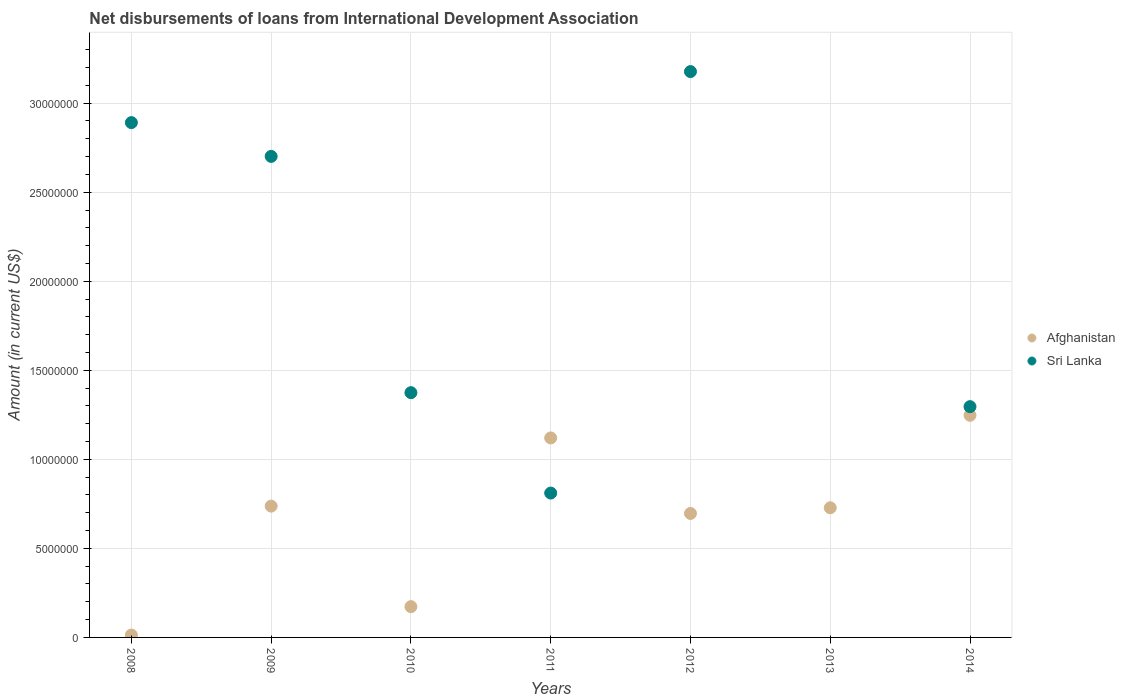How many different coloured dotlines are there?
Keep it short and to the point. 2. Is the number of dotlines equal to the number of legend labels?
Make the answer very short. No. What is the amount of loans disbursed in Afghanistan in 2012?
Offer a terse response. 6.96e+06. Across all years, what is the maximum amount of loans disbursed in Afghanistan?
Offer a very short reply. 1.25e+07. Across all years, what is the minimum amount of loans disbursed in Sri Lanka?
Give a very brief answer. 0. What is the total amount of loans disbursed in Afghanistan in the graph?
Give a very brief answer. 4.72e+07. What is the difference between the amount of loans disbursed in Sri Lanka in 2008 and that in 2014?
Provide a succinct answer. 1.59e+07. What is the difference between the amount of loans disbursed in Afghanistan in 2008 and the amount of loans disbursed in Sri Lanka in 2010?
Give a very brief answer. -1.36e+07. What is the average amount of loans disbursed in Afghanistan per year?
Ensure brevity in your answer.  6.74e+06. In the year 2009, what is the difference between the amount of loans disbursed in Afghanistan and amount of loans disbursed in Sri Lanka?
Keep it short and to the point. -1.96e+07. What is the ratio of the amount of loans disbursed in Afghanistan in 2009 to that in 2013?
Make the answer very short. 1.01. What is the difference between the highest and the second highest amount of loans disbursed in Afghanistan?
Your answer should be compact. 1.27e+06. What is the difference between the highest and the lowest amount of loans disbursed in Sri Lanka?
Your answer should be very brief. 3.18e+07. In how many years, is the amount of loans disbursed in Sri Lanka greater than the average amount of loans disbursed in Sri Lanka taken over all years?
Offer a terse response. 3. Does the amount of loans disbursed in Afghanistan monotonically increase over the years?
Your answer should be very brief. No. How many dotlines are there?
Your response must be concise. 2. What is the difference between two consecutive major ticks on the Y-axis?
Give a very brief answer. 5.00e+06. Does the graph contain grids?
Provide a succinct answer. Yes. How many legend labels are there?
Give a very brief answer. 2. How are the legend labels stacked?
Ensure brevity in your answer.  Vertical. What is the title of the graph?
Your answer should be very brief. Net disbursements of loans from International Development Association. What is the Amount (in current US$) in Afghanistan in 2008?
Provide a succinct answer. 1.33e+05. What is the Amount (in current US$) of Sri Lanka in 2008?
Ensure brevity in your answer.  2.89e+07. What is the Amount (in current US$) of Afghanistan in 2009?
Give a very brief answer. 7.37e+06. What is the Amount (in current US$) of Sri Lanka in 2009?
Your answer should be compact. 2.70e+07. What is the Amount (in current US$) in Afghanistan in 2010?
Offer a very short reply. 1.73e+06. What is the Amount (in current US$) of Sri Lanka in 2010?
Ensure brevity in your answer.  1.37e+07. What is the Amount (in current US$) of Afghanistan in 2011?
Keep it short and to the point. 1.12e+07. What is the Amount (in current US$) in Sri Lanka in 2011?
Your answer should be compact. 8.11e+06. What is the Amount (in current US$) of Afghanistan in 2012?
Give a very brief answer. 6.96e+06. What is the Amount (in current US$) of Sri Lanka in 2012?
Offer a terse response. 3.18e+07. What is the Amount (in current US$) in Afghanistan in 2013?
Offer a terse response. 7.28e+06. What is the Amount (in current US$) of Sri Lanka in 2013?
Keep it short and to the point. 0. What is the Amount (in current US$) in Afghanistan in 2014?
Your response must be concise. 1.25e+07. What is the Amount (in current US$) of Sri Lanka in 2014?
Your answer should be compact. 1.30e+07. Across all years, what is the maximum Amount (in current US$) in Afghanistan?
Your answer should be compact. 1.25e+07. Across all years, what is the maximum Amount (in current US$) in Sri Lanka?
Ensure brevity in your answer.  3.18e+07. Across all years, what is the minimum Amount (in current US$) in Afghanistan?
Provide a short and direct response. 1.33e+05. Across all years, what is the minimum Amount (in current US$) of Sri Lanka?
Ensure brevity in your answer.  0. What is the total Amount (in current US$) in Afghanistan in the graph?
Provide a short and direct response. 4.72e+07. What is the total Amount (in current US$) in Sri Lanka in the graph?
Give a very brief answer. 1.22e+08. What is the difference between the Amount (in current US$) in Afghanistan in 2008 and that in 2009?
Your response must be concise. -7.24e+06. What is the difference between the Amount (in current US$) of Sri Lanka in 2008 and that in 2009?
Give a very brief answer. 1.90e+06. What is the difference between the Amount (in current US$) in Afghanistan in 2008 and that in 2010?
Offer a very short reply. -1.60e+06. What is the difference between the Amount (in current US$) in Sri Lanka in 2008 and that in 2010?
Offer a very short reply. 1.52e+07. What is the difference between the Amount (in current US$) of Afghanistan in 2008 and that in 2011?
Offer a very short reply. -1.11e+07. What is the difference between the Amount (in current US$) of Sri Lanka in 2008 and that in 2011?
Your answer should be compact. 2.08e+07. What is the difference between the Amount (in current US$) in Afghanistan in 2008 and that in 2012?
Keep it short and to the point. -6.83e+06. What is the difference between the Amount (in current US$) in Sri Lanka in 2008 and that in 2012?
Provide a succinct answer. -2.86e+06. What is the difference between the Amount (in current US$) of Afghanistan in 2008 and that in 2013?
Your answer should be very brief. -7.15e+06. What is the difference between the Amount (in current US$) in Afghanistan in 2008 and that in 2014?
Make the answer very short. -1.23e+07. What is the difference between the Amount (in current US$) of Sri Lanka in 2008 and that in 2014?
Make the answer very short. 1.59e+07. What is the difference between the Amount (in current US$) of Afghanistan in 2009 and that in 2010?
Give a very brief answer. 5.64e+06. What is the difference between the Amount (in current US$) of Sri Lanka in 2009 and that in 2010?
Provide a succinct answer. 1.33e+07. What is the difference between the Amount (in current US$) of Afghanistan in 2009 and that in 2011?
Provide a short and direct response. -3.83e+06. What is the difference between the Amount (in current US$) of Sri Lanka in 2009 and that in 2011?
Your answer should be compact. 1.89e+07. What is the difference between the Amount (in current US$) of Afghanistan in 2009 and that in 2012?
Keep it short and to the point. 4.12e+05. What is the difference between the Amount (in current US$) in Sri Lanka in 2009 and that in 2012?
Your answer should be compact. -4.76e+06. What is the difference between the Amount (in current US$) in Afghanistan in 2009 and that in 2013?
Give a very brief answer. 9.30e+04. What is the difference between the Amount (in current US$) in Afghanistan in 2009 and that in 2014?
Your answer should be compact. -5.10e+06. What is the difference between the Amount (in current US$) of Sri Lanka in 2009 and that in 2014?
Your answer should be very brief. 1.41e+07. What is the difference between the Amount (in current US$) in Afghanistan in 2010 and that in 2011?
Your answer should be very brief. -9.47e+06. What is the difference between the Amount (in current US$) of Sri Lanka in 2010 and that in 2011?
Provide a succinct answer. 5.64e+06. What is the difference between the Amount (in current US$) in Afghanistan in 2010 and that in 2012?
Give a very brief answer. -5.23e+06. What is the difference between the Amount (in current US$) in Sri Lanka in 2010 and that in 2012?
Offer a terse response. -1.80e+07. What is the difference between the Amount (in current US$) in Afghanistan in 2010 and that in 2013?
Keep it short and to the point. -5.55e+06. What is the difference between the Amount (in current US$) of Afghanistan in 2010 and that in 2014?
Ensure brevity in your answer.  -1.07e+07. What is the difference between the Amount (in current US$) of Sri Lanka in 2010 and that in 2014?
Provide a succinct answer. 7.85e+05. What is the difference between the Amount (in current US$) of Afghanistan in 2011 and that in 2012?
Ensure brevity in your answer.  4.24e+06. What is the difference between the Amount (in current US$) of Sri Lanka in 2011 and that in 2012?
Your answer should be compact. -2.37e+07. What is the difference between the Amount (in current US$) of Afghanistan in 2011 and that in 2013?
Your response must be concise. 3.92e+06. What is the difference between the Amount (in current US$) in Afghanistan in 2011 and that in 2014?
Offer a very short reply. -1.27e+06. What is the difference between the Amount (in current US$) in Sri Lanka in 2011 and that in 2014?
Make the answer very short. -4.85e+06. What is the difference between the Amount (in current US$) in Afghanistan in 2012 and that in 2013?
Your response must be concise. -3.19e+05. What is the difference between the Amount (in current US$) of Afghanistan in 2012 and that in 2014?
Make the answer very short. -5.51e+06. What is the difference between the Amount (in current US$) in Sri Lanka in 2012 and that in 2014?
Offer a terse response. 1.88e+07. What is the difference between the Amount (in current US$) of Afghanistan in 2013 and that in 2014?
Your answer should be very brief. -5.19e+06. What is the difference between the Amount (in current US$) of Afghanistan in 2008 and the Amount (in current US$) of Sri Lanka in 2009?
Provide a short and direct response. -2.69e+07. What is the difference between the Amount (in current US$) of Afghanistan in 2008 and the Amount (in current US$) of Sri Lanka in 2010?
Keep it short and to the point. -1.36e+07. What is the difference between the Amount (in current US$) in Afghanistan in 2008 and the Amount (in current US$) in Sri Lanka in 2011?
Provide a succinct answer. -7.97e+06. What is the difference between the Amount (in current US$) of Afghanistan in 2008 and the Amount (in current US$) of Sri Lanka in 2012?
Offer a very short reply. -3.16e+07. What is the difference between the Amount (in current US$) in Afghanistan in 2008 and the Amount (in current US$) in Sri Lanka in 2014?
Provide a succinct answer. -1.28e+07. What is the difference between the Amount (in current US$) of Afghanistan in 2009 and the Amount (in current US$) of Sri Lanka in 2010?
Offer a very short reply. -6.37e+06. What is the difference between the Amount (in current US$) of Afghanistan in 2009 and the Amount (in current US$) of Sri Lanka in 2011?
Offer a terse response. -7.33e+05. What is the difference between the Amount (in current US$) of Afghanistan in 2009 and the Amount (in current US$) of Sri Lanka in 2012?
Make the answer very short. -2.44e+07. What is the difference between the Amount (in current US$) in Afghanistan in 2009 and the Amount (in current US$) in Sri Lanka in 2014?
Provide a succinct answer. -5.58e+06. What is the difference between the Amount (in current US$) of Afghanistan in 2010 and the Amount (in current US$) of Sri Lanka in 2011?
Make the answer very short. -6.38e+06. What is the difference between the Amount (in current US$) in Afghanistan in 2010 and the Amount (in current US$) in Sri Lanka in 2012?
Make the answer very short. -3.00e+07. What is the difference between the Amount (in current US$) of Afghanistan in 2010 and the Amount (in current US$) of Sri Lanka in 2014?
Your answer should be compact. -1.12e+07. What is the difference between the Amount (in current US$) of Afghanistan in 2011 and the Amount (in current US$) of Sri Lanka in 2012?
Your answer should be compact. -2.06e+07. What is the difference between the Amount (in current US$) of Afghanistan in 2011 and the Amount (in current US$) of Sri Lanka in 2014?
Offer a terse response. -1.76e+06. What is the difference between the Amount (in current US$) of Afghanistan in 2012 and the Amount (in current US$) of Sri Lanka in 2014?
Provide a succinct answer. -6.00e+06. What is the difference between the Amount (in current US$) of Afghanistan in 2013 and the Amount (in current US$) of Sri Lanka in 2014?
Offer a very short reply. -5.68e+06. What is the average Amount (in current US$) of Afghanistan per year?
Make the answer very short. 6.74e+06. What is the average Amount (in current US$) in Sri Lanka per year?
Offer a terse response. 1.75e+07. In the year 2008, what is the difference between the Amount (in current US$) in Afghanistan and Amount (in current US$) in Sri Lanka?
Provide a short and direct response. -2.88e+07. In the year 2009, what is the difference between the Amount (in current US$) in Afghanistan and Amount (in current US$) in Sri Lanka?
Keep it short and to the point. -1.96e+07. In the year 2010, what is the difference between the Amount (in current US$) of Afghanistan and Amount (in current US$) of Sri Lanka?
Your answer should be very brief. -1.20e+07. In the year 2011, what is the difference between the Amount (in current US$) of Afghanistan and Amount (in current US$) of Sri Lanka?
Your answer should be very brief. 3.10e+06. In the year 2012, what is the difference between the Amount (in current US$) of Afghanistan and Amount (in current US$) of Sri Lanka?
Offer a very short reply. -2.48e+07. In the year 2014, what is the difference between the Amount (in current US$) in Afghanistan and Amount (in current US$) in Sri Lanka?
Offer a terse response. -4.85e+05. What is the ratio of the Amount (in current US$) of Afghanistan in 2008 to that in 2009?
Your answer should be compact. 0.02. What is the ratio of the Amount (in current US$) of Sri Lanka in 2008 to that in 2009?
Keep it short and to the point. 1.07. What is the ratio of the Amount (in current US$) in Afghanistan in 2008 to that in 2010?
Provide a short and direct response. 0.08. What is the ratio of the Amount (in current US$) in Sri Lanka in 2008 to that in 2010?
Offer a very short reply. 2.1. What is the ratio of the Amount (in current US$) in Afghanistan in 2008 to that in 2011?
Offer a terse response. 0.01. What is the ratio of the Amount (in current US$) of Sri Lanka in 2008 to that in 2011?
Give a very brief answer. 3.57. What is the ratio of the Amount (in current US$) in Afghanistan in 2008 to that in 2012?
Your answer should be compact. 0.02. What is the ratio of the Amount (in current US$) in Sri Lanka in 2008 to that in 2012?
Offer a very short reply. 0.91. What is the ratio of the Amount (in current US$) in Afghanistan in 2008 to that in 2013?
Your response must be concise. 0.02. What is the ratio of the Amount (in current US$) in Afghanistan in 2008 to that in 2014?
Provide a short and direct response. 0.01. What is the ratio of the Amount (in current US$) in Sri Lanka in 2008 to that in 2014?
Offer a terse response. 2.23. What is the ratio of the Amount (in current US$) in Afghanistan in 2009 to that in 2010?
Offer a terse response. 4.27. What is the ratio of the Amount (in current US$) of Sri Lanka in 2009 to that in 2010?
Provide a short and direct response. 1.97. What is the ratio of the Amount (in current US$) in Afghanistan in 2009 to that in 2011?
Your response must be concise. 0.66. What is the ratio of the Amount (in current US$) in Sri Lanka in 2009 to that in 2011?
Provide a short and direct response. 3.33. What is the ratio of the Amount (in current US$) in Afghanistan in 2009 to that in 2012?
Your answer should be compact. 1.06. What is the ratio of the Amount (in current US$) of Sri Lanka in 2009 to that in 2012?
Make the answer very short. 0.85. What is the ratio of the Amount (in current US$) in Afghanistan in 2009 to that in 2013?
Offer a terse response. 1.01. What is the ratio of the Amount (in current US$) of Afghanistan in 2009 to that in 2014?
Your answer should be compact. 0.59. What is the ratio of the Amount (in current US$) in Sri Lanka in 2009 to that in 2014?
Your answer should be very brief. 2.08. What is the ratio of the Amount (in current US$) of Afghanistan in 2010 to that in 2011?
Offer a terse response. 0.15. What is the ratio of the Amount (in current US$) in Sri Lanka in 2010 to that in 2011?
Your response must be concise. 1.7. What is the ratio of the Amount (in current US$) in Afghanistan in 2010 to that in 2012?
Provide a succinct answer. 0.25. What is the ratio of the Amount (in current US$) in Sri Lanka in 2010 to that in 2012?
Provide a succinct answer. 0.43. What is the ratio of the Amount (in current US$) in Afghanistan in 2010 to that in 2013?
Give a very brief answer. 0.24. What is the ratio of the Amount (in current US$) of Afghanistan in 2010 to that in 2014?
Your answer should be compact. 0.14. What is the ratio of the Amount (in current US$) of Sri Lanka in 2010 to that in 2014?
Provide a short and direct response. 1.06. What is the ratio of the Amount (in current US$) in Afghanistan in 2011 to that in 2012?
Your answer should be compact. 1.61. What is the ratio of the Amount (in current US$) in Sri Lanka in 2011 to that in 2012?
Offer a terse response. 0.26. What is the ratio of the Amount (in current US$) of Afghanistan in 2011 to that in 2013?
Make the answer very short. 1.54. What is the ratio of the Amount (in current US$) in Afghanistan in 2011 to that in 2014?
Provide a short and direct response. 0.9. What is the ratio of the Amount (in current US$) in Sri Lanka in 2011 to that in 2014?
Offer a very short reply. 0.63. What is the ratio of the Amount (in current US$) of Afghanistan in 2012 to that in 2013?
Give a very brief answer. 0.96. What is the ratio of the Amount (in current US$) in Afghanistan in 2012 to that in 2014?
Make the answer very short. 0.56. What is the ratio of the Amount (in current US$) in Sri Lanka in 2012 to that in 2014?
Offer a terse response. 2.45. What is the ratio of the Amount (in current US$) of Afghanistan in 2013 to that in 2014?
Your answer should be very brief. 0.58. What is the difference between the highest and the second highest Amount (in current US$) of Afghanistan?
Your answer should be very brief. 1.27e+06. What is the difference between the highest and the second highest Amount (in current US$) of Sri Lanka?
Your answer should be compact. 2.86e+06. What is the difference between the highest and the lowest Amount (in current US$) of Afghanistan?
Provide a short and direct response. 1.23e+07. What is the difference between the highest and the lowest Amount (in current US$) in Sri Lanka?
Your answer should be compact. 3.18e+07. 